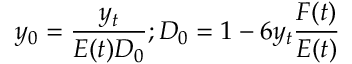Convert formula to latex. <formula><loc_0><loc_0><loc_500><loc_500>y _ { 0 } = \frac { y _ { t } } { E ( t ) D _ { 0 } } ; D _ { 0 } = 1 - 6 y _ { t } \frac { F ( t ) } { E ( t ) }</formula> 